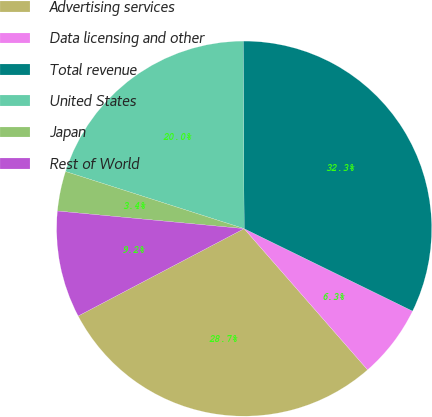Convert chart to OTSL. <chart><loc_0><loc_0><loc_500><loc_500><pie_chart><fcel>Advertising services<fcel>Data licensing and other<fcel>Total revenue<fcel>United States<fcel>Japan<fcel>Rest of World<nl><fcel>28.72%<fcel>6.32%<fcel>32.32%<fcel>19.99%<fcel>3.43%<fcel>9.21%<nl></chart> 